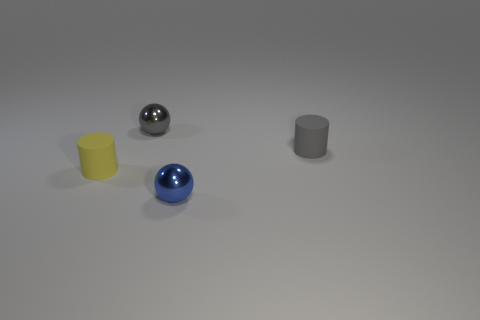Add 1 large cyan shiny cubes. How many objects exist? 5 Subtract all gray spheres. How many spheres are left? 1 Subtract all cyan balls. How many gray cylinders are left? 1 Subtract 2 cylinders. How many cylinders are left? 0 Subtract all purple balls. Subtract all red cylinders. How many balls are left? 2 Subtract all tiny shiny things. Subtract all large metal cylinders. How many objects are left? 2 Add 1 small yellow cylinders. How many small yellow cylinders are left? 2 Add 4 gray objects. How many gray objects exist? 6 Subtract 0 purple cubes. How many objects are left? 4 